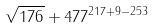Convert formula to latex. <formula><loc_0><loc_0><loc_500><loc_500>\sqrt { 1 7 6 } + 4 7 7 ^ { 2 1 7 + 9 - 2 5 3 }</formula> 